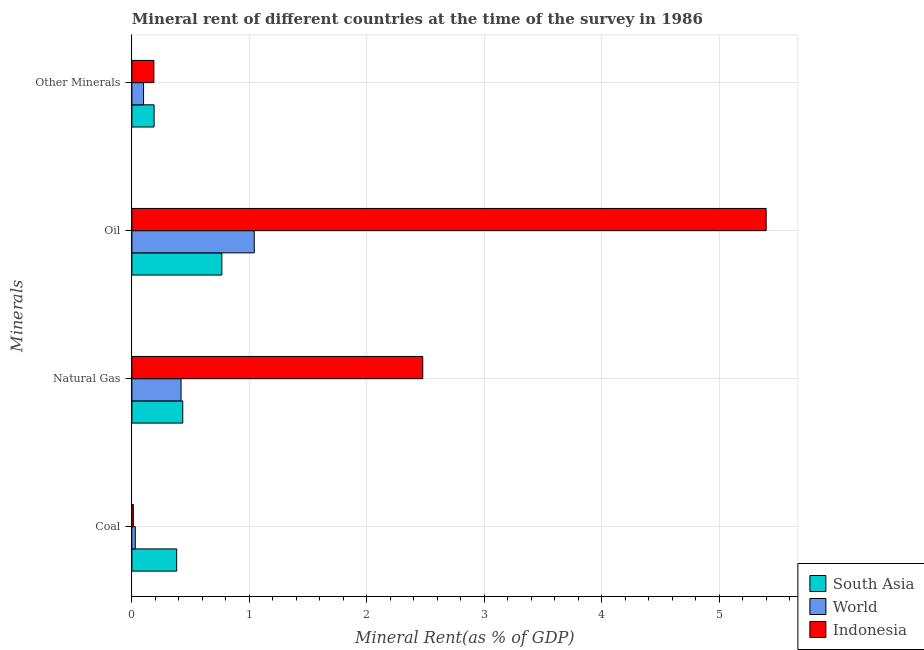Are the number of bars per tick equal to the number of legend labels?
Offer a very short reply. Yes. Are the number of bars on each tick of the Y-axis equal?
Offer a very short reply. Yes. How many bars are there on the 1st tick from the top?
Give a very brief answer. 3. How many bars are there on the 2nd tick from the bottom?
Your answer should be compact. 3. What is the label of the 3rd group of bars from the top?
Keep it short and to the point. Natural Gas. What is the oil rent in South Asia?
Make the answer very short. 0.77. Across all countries, what is the maximum  rent of other minerals?
Offer a very short reply. 0.19. Across all countries, what is the minimum oil rent?
Ensure brevity in your answer.  0.77. In which country was the natural gas rent maximum?
Ensure brevity in your answer.  Indonesia. What is the total oil rent in the graph?
Provide a short and direct response. 7.21. What is the difference between the coal rent in South Asia and that in World?
Give a very brief answer. 0.35. What is the difference between the natural gas rent in World and the  rent of other minerals in South Asia?
Keep it short and to the point. 0.23. What is the average coal rent per country?
Your response must be concise. 0.14. What is the difference between the natural gas rent and oil rent in South Asia?
Offer a very short reply. -0.33. In how many countries, is the natural gas rent greater than 0.2 %?
Keep it short and to the point. 3. What is the ratio of the coal rent in South Asia to that in World?
Provide a short and direct response. 13.02. What is the difference between the highest and the second highest  rent of other minerals?
Offer a terse response. 0. What is the difference between the highest and the lowest oil rent?
Provide a succinct answer. 4.63. Is the sum of the natural gas rent in World and Indonesia greater than the maximum  rent of other minerals across all countries?
Your response must be concise. Yes. Is it the case that in every country, the sum of the  rent of other minerals and natural gas rent is greater than the sum of coal rent and oil rent?
Ensure brevity in your answer.  No. What does the 3rd bar from the top in Other Minerals represents?
Offer a very short reply. South Asia. Is it the case that in every country, the sum of the coal rent and natural gas rent is greater than the oil rent?
Make the answer very short. No. Are all the bars in the graph horizontal?
Provide a succinct answer. Yes. How many countries are there in the graph?
Offer a very short reply. 3. What is the title of the graph?
Provide a short and direct response. Mineral rent of different countries at the time of the survey in 1986. What is the label or title of the X-axis?
Ensure brevity in your answer.  Mineral Rent(as % of GDP). What is the label or title of the Y-axis?
Provide a succinct answer. Minerals. What is the Mineral Rent(as % of GDP) of South Asia in Coal?
Give a very brief answer. 0.38. What is the Mineral Rent(as % of GDP) in World in Coal?
Give a very brief answer. 0.03. What is the Mineral Rent(as % of GDP) of Indonesia in Coal?
Your answer should be compact. 0.01. What is the Mineral Rent(as % of GDP) of South Asia in Natural Gas?
Your answer should be very brief. 0.43. What is the Mineral Rent(as % of GDP) in World in Natural Gas?
Provide a succinct answer. 0.42. What is the Mineral Rent(as % of GDP) of Indonesia in Natural Gas?
Make the answer very short. 2.48. What is the Mineral Rent(as % of GDP) of South Asia in Oil?
Ensure brevity in your answer.  0.77. What is the Mineral Rent(as % of GDP) in World in Oil?
Provide a short and direct response. 1.04. What is the Mineral Rent(as % of GDP) of Indonesia in Oil?
Your response must be concise. 5.4. What is the Mineral Rent(as % of GDP) in South Asia in Other Minerals?
Provide a short and direct response. 0.19. What is the Mineral Rent(as % of GDP) of World in Other Minerals?
Offer a very short reply. 0.1. What is the Mineral Rent(as % of GDP) of Indonesia in Other Minerals?
Your answer should be compact. 0.19. Across all Minerals, what is the maximum Mineral Rent(as % of GDP) of South Asia?
Make the answer very short. 0.77. Across all Minerals, what is the maximum Mineral Rent(as % of GDP) in World?
Your answer should be very brief. 1.04. Across all Minerals, what is the maximum Mineral Rent(as % of GDP) in Indonesia?
Provide a succinct answer. 5.4. Across all Minerals, what is the minimum Mineral Rent(as % of GDP) of South Asia?
Offer a very short reply. 0.19. Across all Minerals, what is the minimum Mineral Rent(as % of GDP) of World?
Give a very brief answer. 0.03. Across all Minerals, what is the minimum Mineral Rent(as % of GDP) of Indonesia?
Give a very brief answer. 0.01. What is the total Mineral Rent(as % of GDP) in South Asia in the graph?
Offer a terse response. 1.77. What is the total Mineral Rent(as % of GDP) of World in the graph?
Your response must be concise. 1.59. What is the total Mineral Rent(as % of GDP) in Indonesia in the graph?
Provide a short and direct response. 8.08. What is the difference between the Mineral Rent(as % of GDP) in South Asia in Coal and that in Natural Gas?
Give a very brief answer. -0.05. What is the difference between the Mineral Rent(as % of GDP) of World in Coal and that in Natural Gas?
Provide a short and direct response. -0.39. What is the difference between the Mineral Rent(as % of GDP) of Indonesia in Coal and that in Natural Gas?
Offer a terse response. -2.46. What is the difference between the Mineral Rent(as % of GDP) of South Asia in Coal and that in Oil?
Provide a short and direct response. -0.38. What is the difference between the Mineral Rent(as % of GDP) of World in Coal and that in Oil?
Keep it short and to the point. -1.01. What is the difference between the Mineral Rent(as % of GDP) in Indonesia in Coal and that in Oil?
Provide a short and direct response. -5.39. What is the difference between the Mineral Rent(as % of GDP) in South Asia in Coal and that in Other Minerals?
Your answer should be very brief. 0.19. What is the difference between the Mineral Rent(as % of GDP) in World in Coal and that in Other Minerals?
Provide a succinct answer. -0.07. What is the difference between the Mineral Rent(as % of GDP) of Indonesia in Coal and that in Other Minerals?
Keep it short and to the point. -0.18. What is the difference between the Mineral Rent(as % of GDP) in South Asia in Natural Gas and that in Oil?
Your response must be concise. -0.33. What is the difference between the Mineral Rent(as % of GDP) in World in Natural Gas and that in Oil?
Make the answer very short. -0.62. What is the difference between the Mineral Rent(as % of GDP) in Indonesia in Natural Gas and that in Oil?
Provide a succinct answer. -2.92. What is the difference between the Mineral Rent(as % of GDP) of South Asia in Natural Gas and that in Other Minerals?
Offer a very short reply. 0.24. What is the difference between the Mineral Rent(as % of GDP) in World in Natural Gas and that in Other Minerals?
Your response must be concise. 0.32. What is the difference between the Mineral Rent(as % of GDP) in Indonesia in Natural Gas and that in Other Minerals?
Provide a succinct answer. 2.29. What is the difference between the Mineral Rent(as % of GDP) in South Asia in Oil and that in Other Minerals?
Provide a short and direct response. 0.58. What is the difference between the Mineral Rent(as % of GDP) of World in Oil and that in Other Minerals?
Offer a terse response. 0.94. What is the difference between the Mineral Rent(as % of GDP) in Indonesia in Oil and that in Other Minerals?
Provide a succinct answer. 5.21. What is the difference between the Mineral Rent(as % of GDP) of South Asia in Coal and the Mineral Rent(as % of GDP) of World in Natural Gas?
Your answer should be very brief. -0.04. What is the difference between the Mineral Rent(as % of GDP) in South Asia in Coal and the Mineral Rent(as % of GDP) in Indonesia in Natural Gas?
Keep it short and to the point. -2.1. What is the difference between the Mineral Rent(as % of GDP) in World in Coal and the Mineral Rent(as % of GDP) in Indonesia in Natural Gas?
Your answer should be compact. -2.45. What is the difference between the Mineral Rent(as % of GDP) of South Asia in Coal and the Mineral Rent(as % of GDP) of World in Oil?
Your answer should be compact. -0.66. What is the difference between the Mineral Rent(as % of GDP) in South Asia in Coal and the Mineral Rent(as % of GDP) in Indonesia in Oil?
Ensure brevity in your answer.  -5.02. What is the difference between the Mineral Rent(as % of GDP) of World in Coal and the Mineral Rent(as % of GDP) of Indonesia in Oil?
Your answer should be very brief. -5.37. What is the difference between the Mineral Rent(as % of GDP) in South Asia in Coal and the Mineral Rent(as % of GDP) in World in Other Minerals?
Offer a very short reply. 0.28. What is the difference between the Mineral Rent(as % of GDP) of South Asia in Coal and the Mineral Rent(as % of GDP) of Indonesia in Other Minerals?
Offer a very short reply. 0.19. What is the difference between the Mineral Rent(as % of GDP) in World in Coal and the Mineral Rent(as % of GDP) in Indonesia in Other Minerals?
Offer a terse response. -0.16. What is the difference between the Mineral Rent(as % of GDP) of South Asia in Natural Gas and the Mineral Rent(as % of GDP) of World in Oil?
Provide a succinct answer. -0.61. What is the difference between the Mineral Rent(as % of GDP) in South Asia in Natural Gas and the Mineral Rent(as % of GDP) in Indonesia in Oil?
Make the answer very short. -4.97. What is the difference between the Mineral Rent(as % of GDP) in World in Natural Gas and the Mineral Rent(as % of GDP) in Indonesia in Oil?
Your response must be concise. -4.98. What is the difference between the Mineral Rent(as % of GDP) of South Asia in Natural Gas and the Mineral Rent(as % of GDP) of World in Other Minerals?
Make the answer very short. 0.33. What is the difference between the Mineral Rent(as % of GDP) in South Asia in Natural Gas and the Mineral Rent(as % of GDP) in Indonesia in Other Minerals?
Your answer should be very brief. 0.25. What is the difference between the Mineral Rent(as % of GDP) of World in Natural Gas and the Mineral Rent(as % of GDP) of Indonesia in Other Minerals?
Ensure brevity in your answer.  0.23. What is the difference between the Mineral Rent(as % of GDP) in South Asia in Oil and the Mineral Rent(as % of GDP) in World in Other Minerals?
Ensure brevity in your answer.  0.67. What is the difference between the Mineral Rent(as % of GDP) of South Asia in Oil and the Mineral Rent(as % of GDP) of Indonesia in Other Minerals?
Your response must be concise. 0.58. What is the difference between the Mineral Rent(as % of GDP) of World in Oil and the Mineral Rent(as % of GDP) of Indonesia in Other Minerals?
Make the answer very short. 0.85. What is the average Mineral Rent(as % of GDP) in South Asia per Minerals?
Your answer should be compact. 0.44. What is the average Mineral Rent(as % of GDP) in World per Minerals?
Keep it short and to the point. 0.4. What is the average Mineral Rent(as % of GDP) of Indonesia per Minerals?
Your answer should be very brief. 2.02. What is the difference between the Mineral Rent(as % of GDP) in South Asia and Mineral Rent(as % of GDP) in World in Coal?
Your answer should be very brief. 0.35. What is the difference between the Mineral Rent(as % of GDP) of South Asia and Mineral Rent(as % of GDP) of Indonesia in Coal?
Make the answer very short. 0.37. What is the difference between the Mineral Rent(as % of GDP) of World and Mineral Rent(as % of GDP) of Indonesia in Coal?
Your answer should be compact. 0.02. What is the difference between the Mineral Rent(as % of GDP) in South Asia and Mineral Rent(as % of GDP) in World in Natural Gas?
Your answer should be compact. 0.01. What is the difference between the Mineral Rent(as % of GDP) in South Asia and Mineral Rent(as % of GDP) in Indonesia in Natural Gas?
Make the answer very short. -2.04. What is the difference between the Mineral Rent(as % of GDP) of World and Mineral Rent(as % of GDP) of Indonesia in Natural Gas?
Your answer should be compact. -2.06. What is the difference between the Mineral Rent(as % of GDP) of South Asia and Mineral Rent(as % of GDP) of World in Oil?
Give a very brief answer. -0.28. What is the difference between the Mineral Rent(as % of GDP) of South Asia and Mineral Rent(as % of GDP) of Indonesia in Oil?
Your response must be concise. -4.63. What is the difference between the Mineral Rent(as % of GDP) in World and Mineral Rent(as % of GDP) in Indonesia in Oil?
Your response must be concise. -4.36. What is the difference between the Mineral Rent(as % of GDP) in South Asia and Mineral Rent(as % of GDP) in World in Other Minerals?
Keep it short and to the point. 0.09. What is the difference between the Mineral Rent(as % of GDP) in South Asia and Mineral Rent(as % of GDP) in Indonesia in Other Minerals?
Make the answer very short. 0. What is the difference between the Mineral Rent(as % of GDP) of World and Mineral Rent(as % of GDP) of Indonesia in Other Minerals?
Ensure brevity in your answer.  -0.09. What is the ratio of the Mineral Rent(as % of GDP) in South Asia in Coal to that in Natural Gas?
Provide a succinct answer. 0.88. What is the ratio of the Mineral Rent(as % of GDP) in World in Coal to that in Natural Gas?
Offer a terse response. 0.07. What is the ratio of the Mineral Rent(as % of GDP) in Indonesia in Coal to that in Natural Gas?
Provide a succinct answer. 0.01. What is the ratio of the Mineral Rent(as % of GDP) in South Asia in Coal to that in Oil?
Your answer should be compact. 0.5. What is the ratio of the Mineral Rent(as % of GDP) of World in Coal to that in Oil?
Keep it short and to the point. 0.03. What is the ratio of the Mineral Rent(as % of GDP) of Indonesia in Coal to that in Oil?
Your answer should be compact. 0. What is the ratio of the Mineral Rent(as % of GDP) in South Asia in Coal to that in Other Minerals?
Make the answer very short. 2.02. What is the ratio of the Mineral Rent(as % of GDP) in World in Coal to that in Other Minerals?
Provide a short and direct response. 0.29. What is the ratio of the Mineral Rent(as % of GDP) in Indonesia in Coal to that in Other Minerals?
Your answer should be compact. 0.07. What is the ratio of the Mineral Rent(as % of GDP) of South Asia in Natural Gas to that in Oil?
Your answer should be very brief. 0.57. What is the ratio of the Mineral Rent(as % of GDP) in World in Natural Gas to that in Oil?
Provide a succinct answer. 0.4. What is the ratio of the Mineral Rent(as % of GDP) in Indonesia in Natural Gas to that in Oil?
Offer a very short reply. 0.46. What is the ratio of the Mineral Rent(as % of GDP) of South Asia in Natural Gas to that in Other Minerals?
Your response must be concise. 2.29. What is the ratio of the Mineral Rent(as % of GDP) in World in Natural Gas to that in Other Minerals?
Offer a terse response. 4.21. What is the ratio of the Mineral Rent(as % of GDP) of Indonesia in Natural Gas to that in Other Minerals?
Make the answer very short. 13.21. What is the ratio of the Mineral Rent(as % of GDP) of South Asia in Oil to that in Other Minerals?
Keep it short and to the point. 4.05. What is the ratio of the Mineral Rent(as % of GDP) of World in Oil to that in Other Minerals?
Offer a very short reply. 10.47. What is the ratio of the Mineral Rent(as % of GDP) in Indonesia in Oil to that in Other Minerals?
Your answer should be very brief. 28.81. What is the difference between the highest and the second highest Mineral Rent(as % of GDP) of South Asia?
Keep it short and to the point. 0.33. What is the difference between the highest and the second highest Mineral Rent(as % of GDP) of World?
Your response must be concise. 0.62. What is the difference between the highest and the second highest Mineral Rent(as % of GDP) of Indonesia?
Offer a terse response. 2.92. What is the difference between the highest and the lowest Mineral Rent(as % of GDP) of South Asia?
Make the answer very short. 0.58. What is the difference between the highest and the lowest Mineral Rent(as % of GDP) of World?
Make the answer very short. 1.01. What is the difference between the highest and the lowest Mineral Rent(as % of GDP) of Indonesia?
Keep it short and to the point. 5.39. 